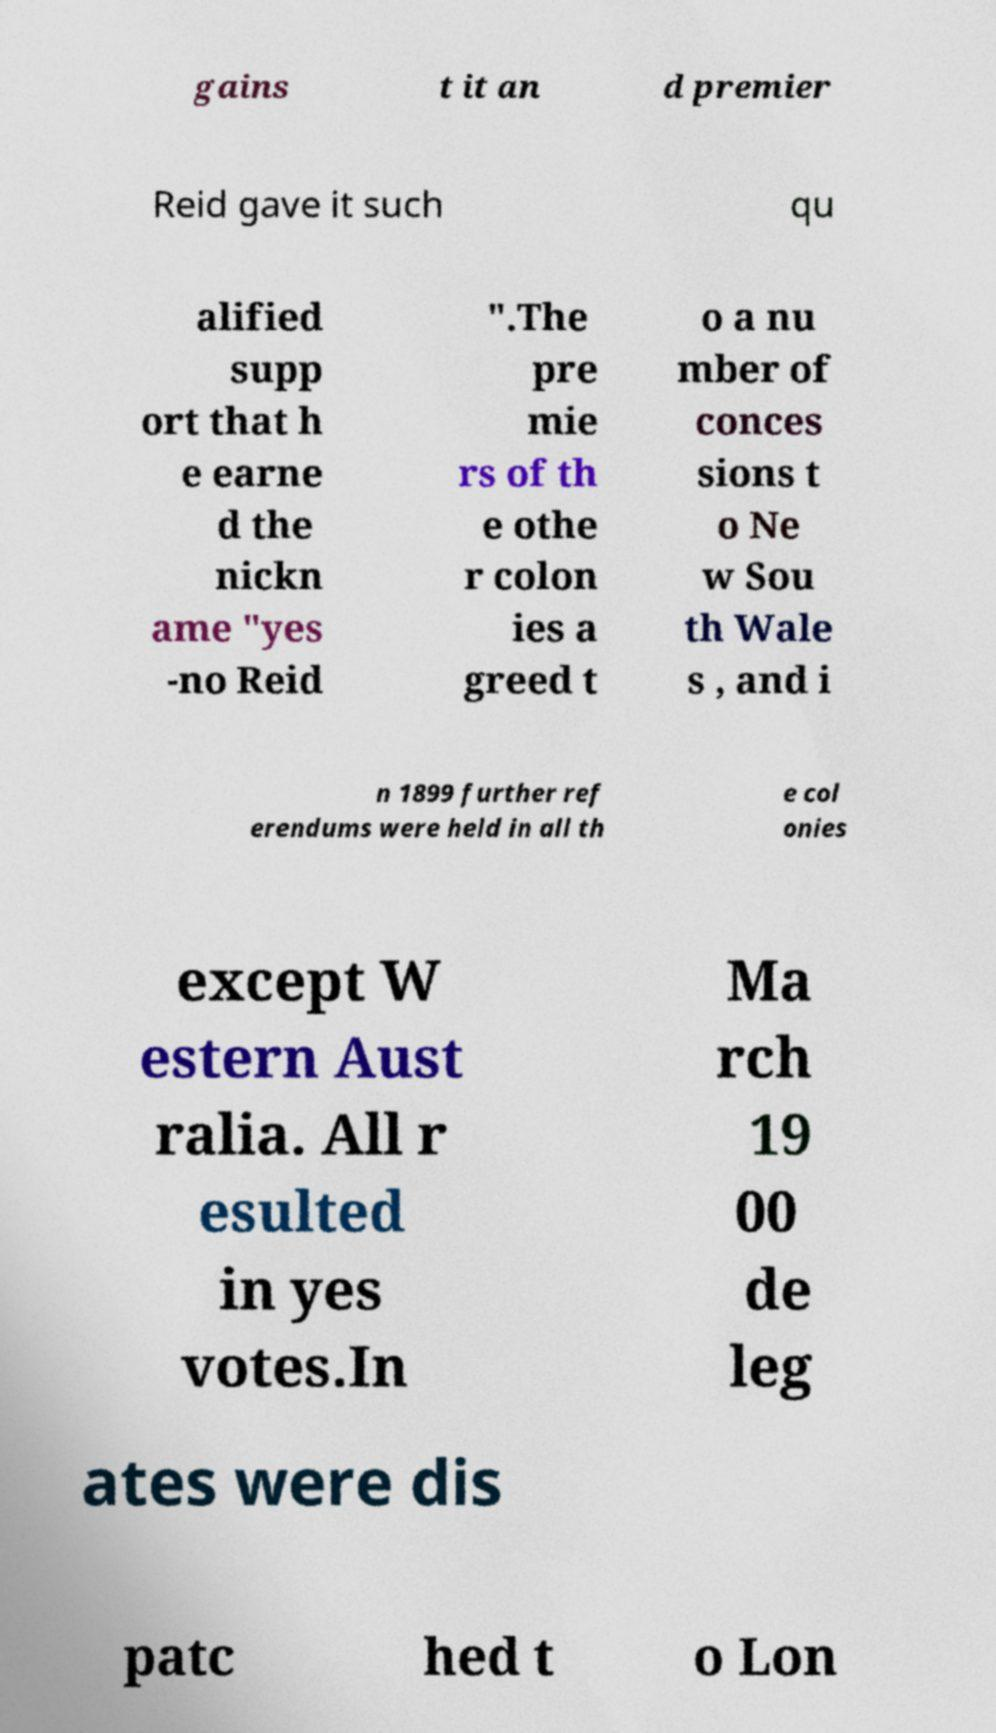Please identify and transcribe the text found in this image. gains t it an d premier Reid gave it such qu alified supp ort that h e earne d the nickn ame "yes -no Reid ".The pre mie rs of th e othe r colon ies a greed t o a nu mber of conces sions t o Ne w Sou th Wale s , and i n 1899 further ref erendums were held in all th e col onies except W estern Aust ralia. All r esulted in yes votes.In Ma rch 19 00 de leg ates were dis patc hed t o Lon 